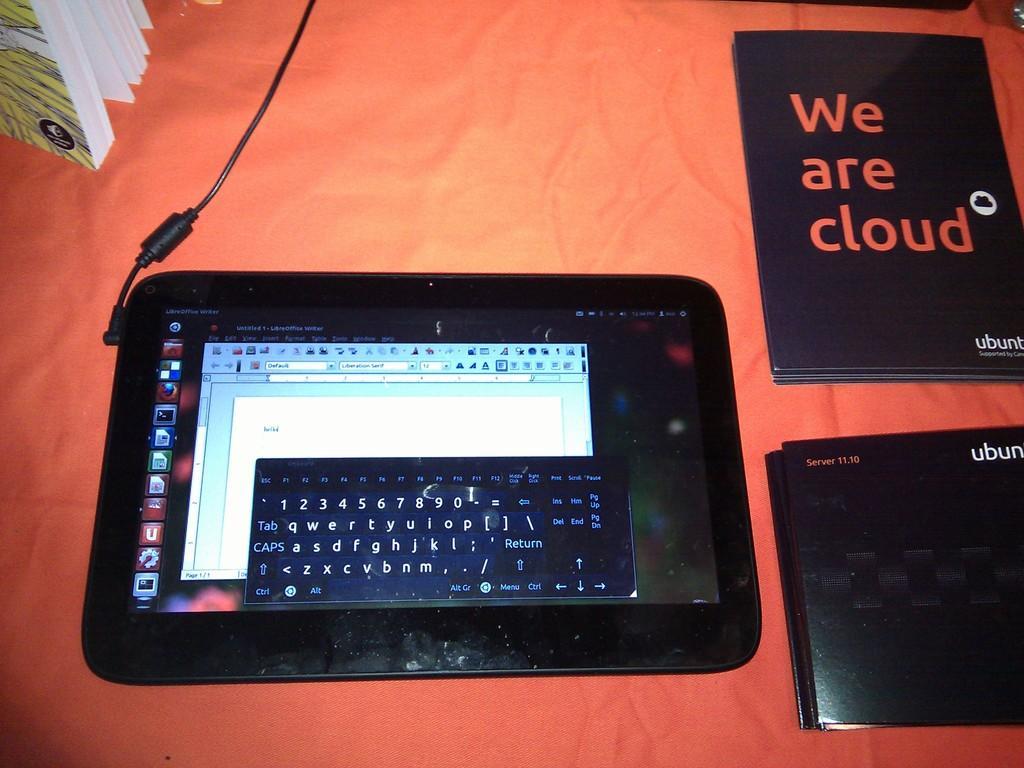How would you summarize this image in a sentence or two? In this image I can see a tab, few books on some surface and the background is in orange color. 